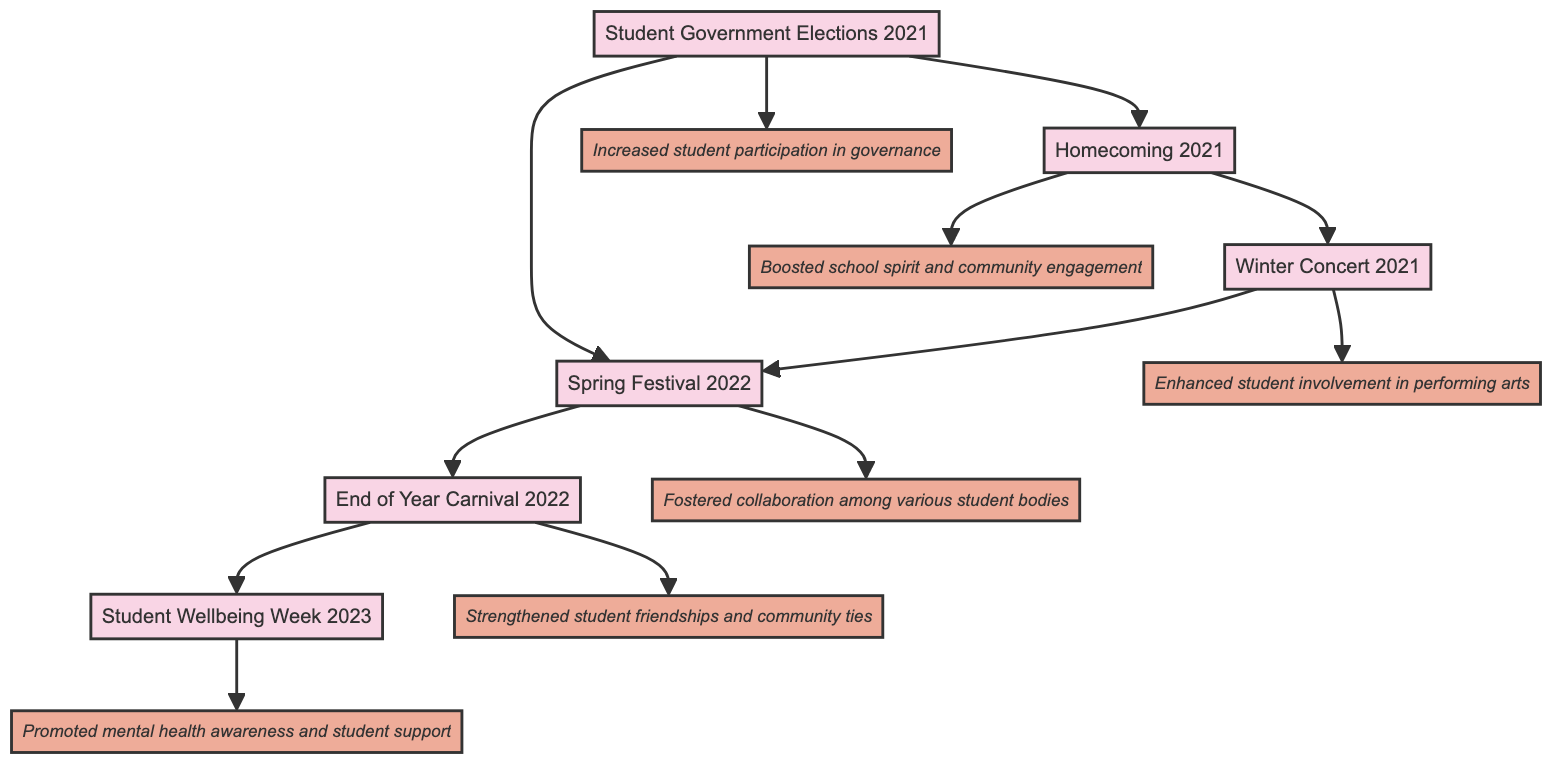What is the impact of the End of Year Carnival 2022? The impact of the End of Year Carnival 2022 is noted in the diagram as "Strengthened student friendships and community ties." There is an arrow pointing from the event node to its corresponding impact node, confirming this relationship.
Answer: Strengthened student friendships and community ties How many events are connected to the Student Government Elections 2021? The diagram shows two arrows originating from the Student Government Elections 2021 event node, connecting it to Homecoming 2021 and Spring Festival 2022. Therefore, the number of connected events is determined by counting these arrows.
Answer: 2 Which event is directly connected to Student Wellbeing Week 2023? Observing the directed graph, there is one arrow directed from End of Year Carnival 2022 to Student Wellbeing Week 2023, indicating that the End of Year Carnival 2022 is directly connected to this event.
Answer: End of Year Carnival 2022 What was the impact of the Winter Concert 2021? The directed graph specifies the impact of the Winter Concert 2021 as "Enhanced student involvement in performing arts." This is visible in the diagram where the event node points to its respective impact node.
Answer: Enhanced student involvement in performing arts Which event had an impact on both Homecoming 2021 and Spring Festival 2022? By tracing the arrows in the diagram, Winter Concert 2021 is shown to connect directly to both Homecoming 2021 and Spring Festival 2022. This indicates it had a direct impact on both events.
Answer: Winter Concert 2021 What is the total number of events represented in the diagram? The diagram includes six distinct event nodes: Student Government Elections 2021, Homecoming 2021, Winter Concert 2021, Spring Festival 2022, End of Year Carnival 2022, and Student Wellbeing Week 2023. Counting these yields the total number of events.
Answer: 6 Which two events are connected to Spring Festival 2022? In the diagram, two arrows are noted that lead out from Spring Festival 2022; one points to End of Year Carnival 2022 and another leads back to Winter Concert 2021, thus identifying these two events as connected to Spring Festival 2022.
Answer: Winter Concert 2021, End of Year Carnival 2022 What is the primary theme of Student Wellbeing Week 2023? The diagram shows the impact of Student Wellbeing Week 2023 as "Promoted mental health awareness and student support." This directly states the primary theme associated with this event according to the connections in the directed graph.
Answer: Promoted mental health awareness and student support 